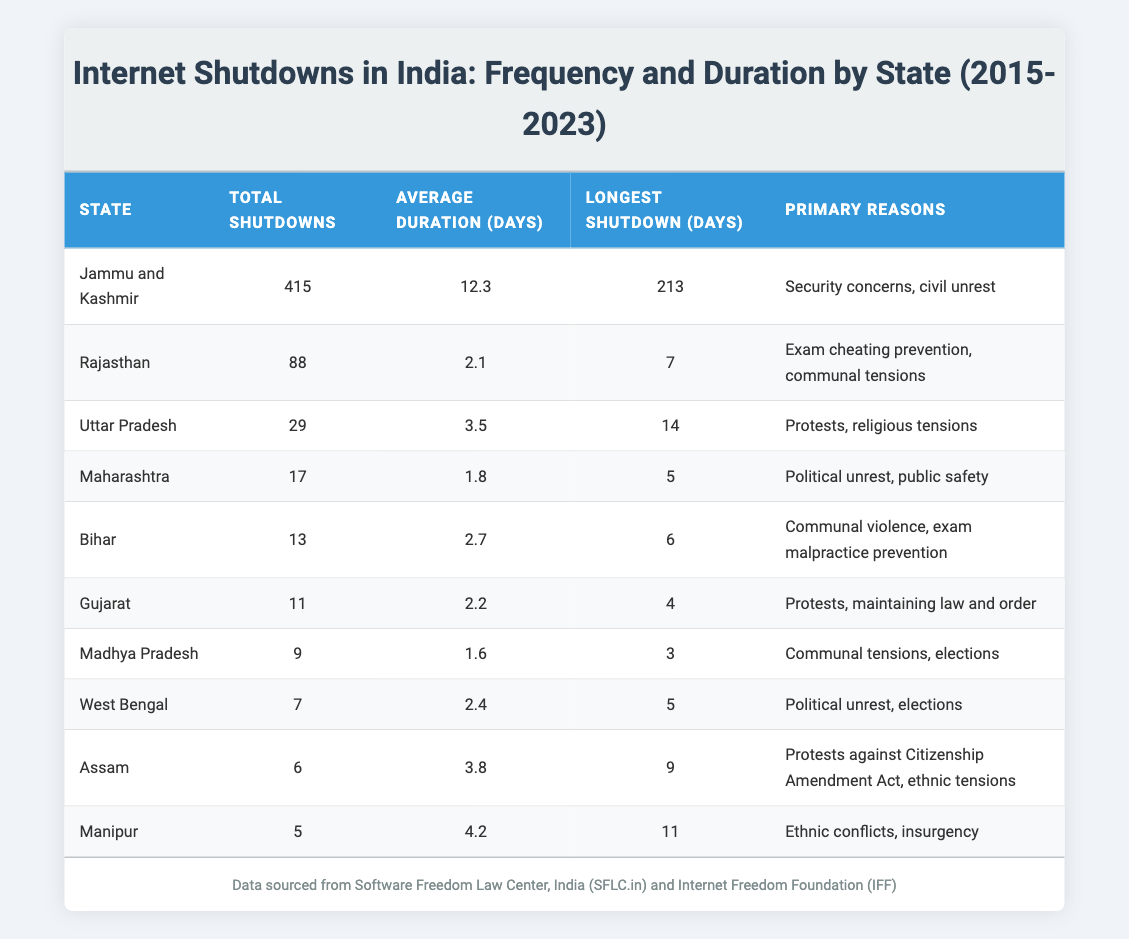What is the state with the highest number of internet shutdowns? The table shows that Jammu and Kashmir has the highest total shutdowns with 415 instances, which is greater than any other state listed.
Answer: Jammu and Kashmir What is the average duration of internet shutdowns in Rajasthan? The table indicates that the average duration of internet shutdowns in Rajasthan is 2.1 days as listed in the corresponding row for this state.
Answer: 2.1 days Which state experienced the longest internet shutdown and how many days did it last? According to the table, Jammu and Kashmir experienced the longest shutdown, which lasted for 213 days, as per the "Longest Shutdown (days)" column.
Answer: Jammu and Kashmir, 213 days Is the average duration of internet shutdowns in Assam greater than that in Uttar Pradesh? The average duration in Assam is 3.8 days, while in Uttar Pradesh it is 3.5 days; hence the average in Assam is greater.
Answer: Yes What is the total number of internet shutdowns in Maharashtra and Gujarat combined? Adding the total shutdowns in Maharashtra (17) and Gujarat (11) gives 28; therefore, the combined total is calculated as 17 + 11 = 28.
Answer: 28 What is the primary reason for internet shutdowns in Bihar? The table specifies that the primary reasons for internet shutdowns in Bihar are communal violence and exam malpractice prevention according to the data provided.
Answer: Communal violence, exam malpractice prevention How many states have experienced more than 10 shutdowns? By analyzing the table, Jammu and Kashmir, Rajasthan, and Uttar Pradesh have shutdowns greater than 10, making it a total of 3 states.
Answer: 3 states What is the median average duration of shutdowns across all listed states? To find the median, we must first arrange the average durations: 1.6, 1.8, 2.1, 2.2, 2.4, 2.7, 3.5, 3.8, 4.2, and 12.3 (in increasing order); since there are 10 values, the median is the average of the 5th and 6th values (2.7 and 3.5), which yields (2.7 + 3.5)/2 = 3.1 days.
Answer: 3.1 days 